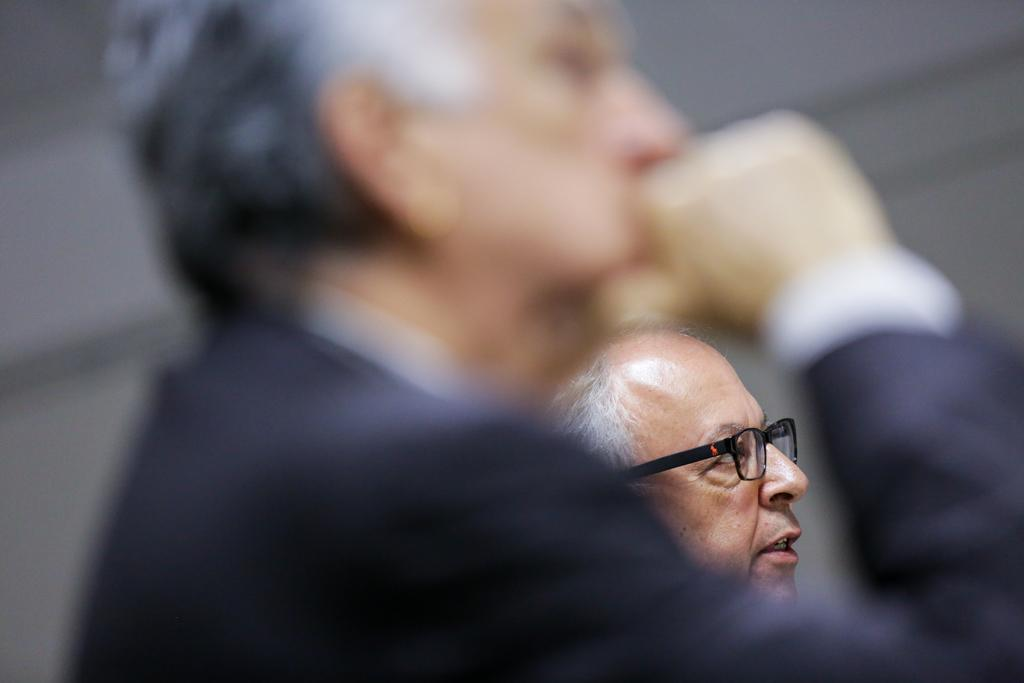How many people are in the image? There are two persons in the image. Can you describe one of the persons in the image? One of the persons is wearing spectacles. What type of silk is being spun by the pot in the image? There is no pot or silk present in the image. How many fangs can be seen on the person wearing spectacles in the image? There are no fangs visible on the person wearing spectacles in the image. 